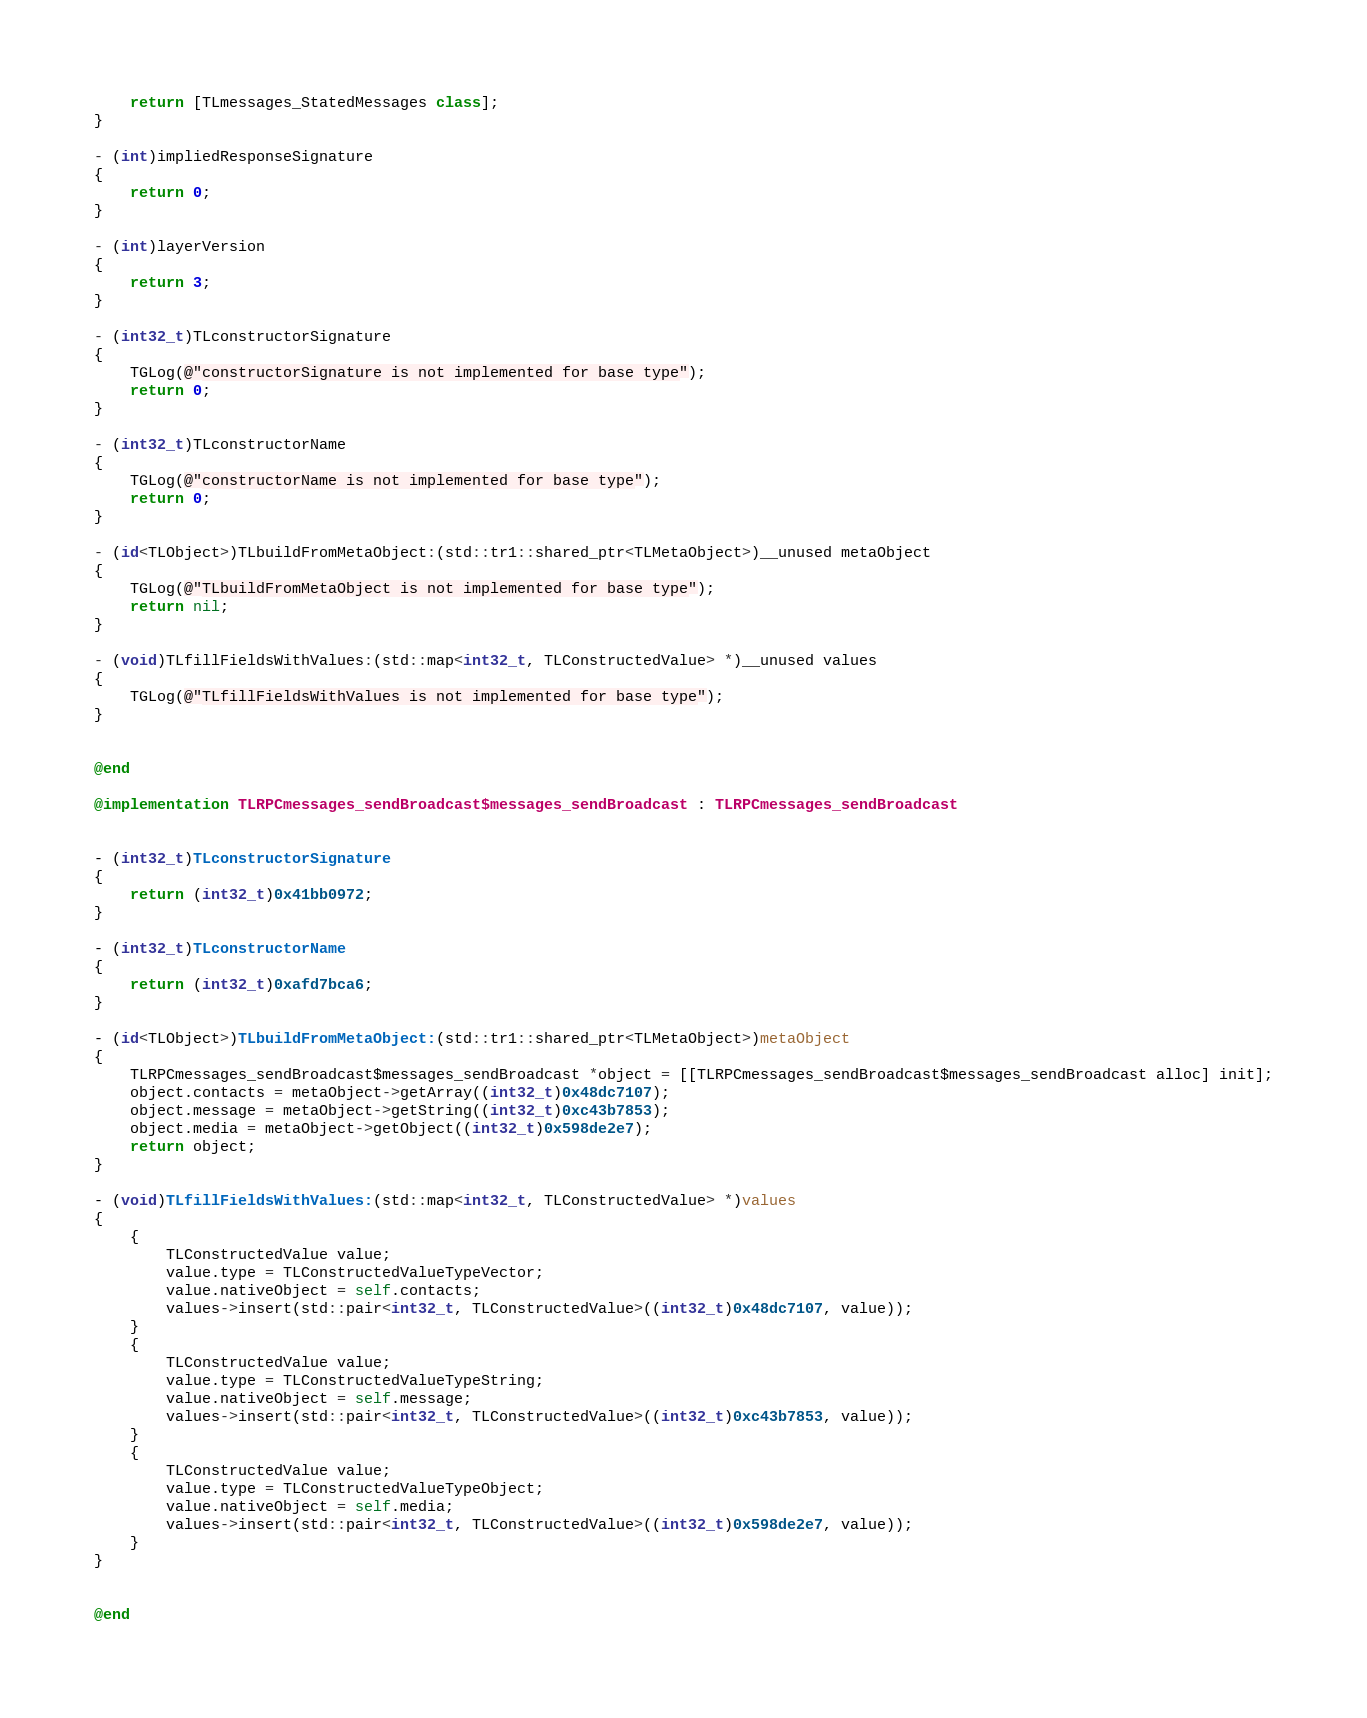Convert code to text. <code><loc_0><loc_0><loc_500><loc_500><_ObjectiveC_>    return [TLmessages_StatedMessages class];
}

- (int)impliedResponseSignature
{
    return 0;
}

- (int)layerVersion
{
    return 3;
}

- (int32_t)TLconstructorSignature
{
    TGLog(@"constructorSignature is not implemented for base type");
    return 0;
}

- (int32_t)TLconstructorName
{
    TGLog(@"constructorName is not implemented for base type");
    return 0;
}

- (id<TLObject>)TLbuildFromMetaObject:(std::tr1::shared_ptr<TLMetaObject>)__unused metaObject
{
    TGLog(@"TLbuildFromMetaObject is not implemented for base type");
    return nil;
}

- (void)TLfillFieldsWithValues:(std::map<int32_t, TLConstructedValue> *)__unused values
{
    TGLog(@"TLfillFieldsWithValues is not implemented for base type");
}


@end

@implementation TLRPCmessages_sendBroadcast$messages_sendBroadcast : TLRPCmessages_sendBroadcast


- (int32_t)TLconstructorSignature
{
    return (int32_t)0x41bb0972;
}

- (int32_t)TLconstructorName
{
    return (int32_t)0xafd7bca6;
}

- (id<TLObject>)TLbuildFromMetaObject:(std::tr1::shared_ptr<TLMetaObject>)metaObject
{
    TLRPCmessages_sendBroadcast$messages_sendBroadcast *object = [[TLRPCmessages_sendBroadcast$messages_sendBroadcast alloc] init];
    object.contacts = metaObject->getArray((int32_t)0x48dc7107);
    object.message = metaObject->getString((int32_t)0xc43b7853);
    object.media = metaObject->getObject((int32_t)0x598de2e7);
    return object;
}

- (void)TLfillFieldsWithValues:(std::map<int32_t, TLConstructedValue> *)values
{
    {
        TLConstructedValue value;
        value.type = TLConstructedValueTypeVector;
        value.nativeObject = self.contacts;
        values->insert(std::pair<int32_t, TLConstructedValue>((int32_t)0x48dc7107, value));
    }
    {
        TLConstructedValue value;
        value.type = TLConstructedValueTypeString;
        value.nativeObject = self.message;
        values->insert(std::pair<int32_t, TLConstructedValue>((int32_t)0xc43b7853, value));
    }
    {
        TLConstructedValue value;
        value.type = TLConstructedValueTypeObject;
        value.nativeObject = self.media;
        values->insert(std::pair<int32_t, TLConstructedValue>((int32_t)0x598de2e7, value));
    }
}


@end

</code> 